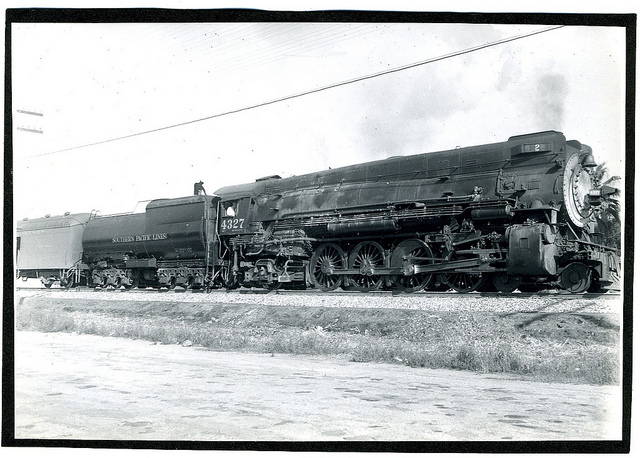Is there any indication of what this train might have been used for? Given the robust size and construction of the locomotive, along with its tender car, it's plausible that it was used for long-distance travel or heavy freight, serving as a workhorse of the rails during its operational period. 